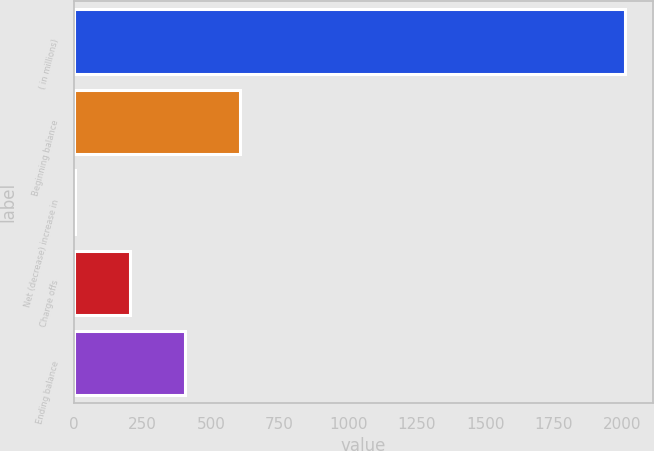Convert chart to OTSL. <chart><loc_0><loc_0><loc_500><loc_500><bar_chart><fcel>( in millions)<fcel>Beginning balance<fcel>Net (decrease) increase in<fcel>Charge offs<fcel>Ending balance<nl><fcel>2012<fcel>607.1<fcel>5<fcel>205.7<fcel>406.4<nl></chart> 